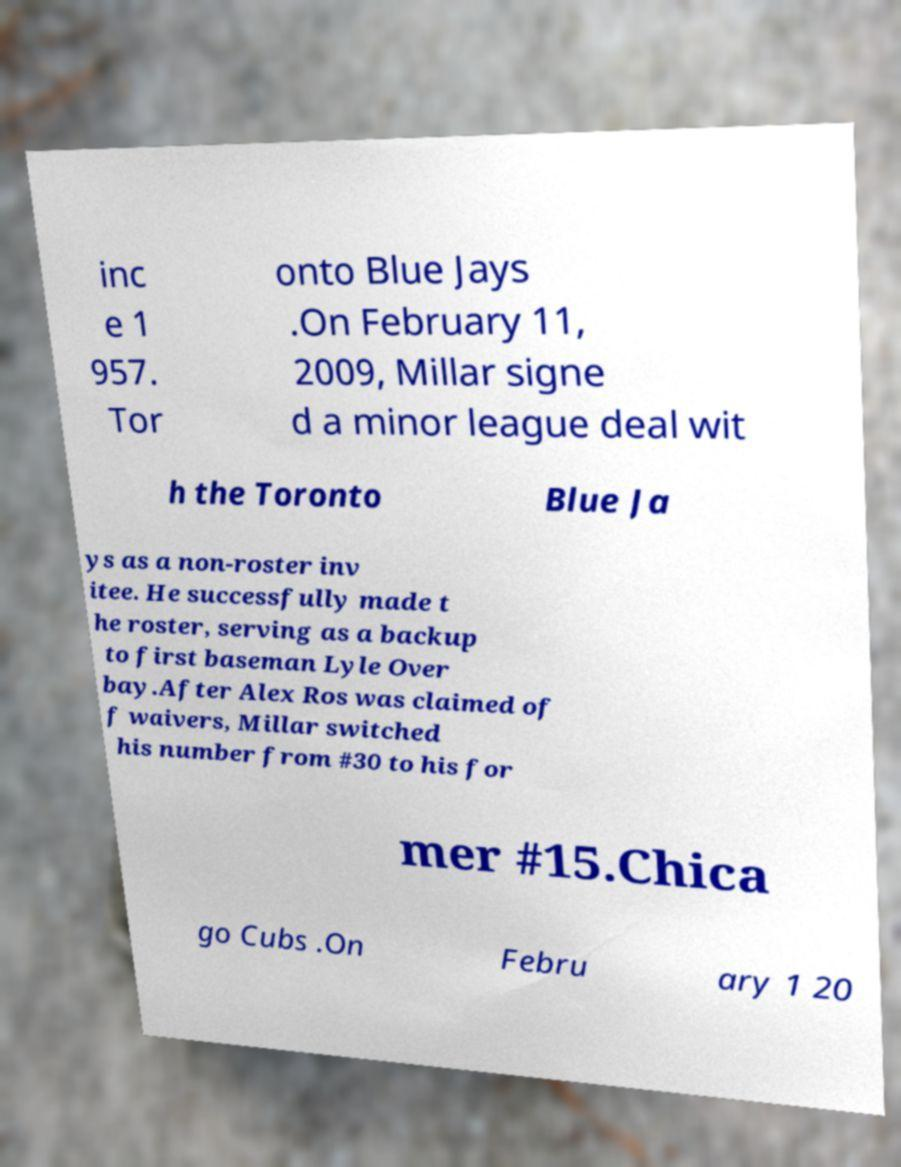Could you assist in decoding the text presented in this image and type it out clearly? inc e 1 957. Tor onto Blue Jays .On February 11, 2009, Millar signe d a minor league deal wit h the Toronto Blue Ja ys as a non-roster inv itee. He successfully made t he roster, serving as a backup to first baseman Lyle Over bay.After Alex Ros was claimed of f waivers, Millar switched his number from #30 to his for mer #15.Chica go Cubs .On Febru ary 1 20 